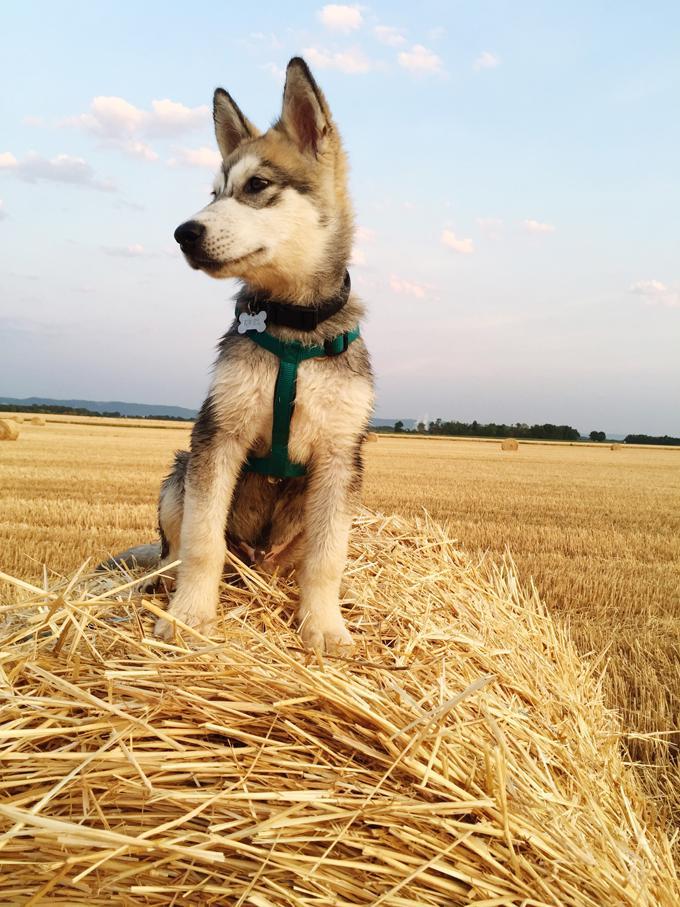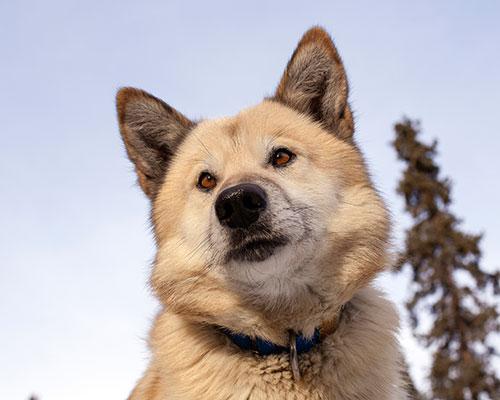The first image is the image on the left, the second image is the image on the right. Analyze the images presented: Is the assertion "The left and right image contains the same number of dogs with one sitting and the other standing outside." valid? Answer yes or no. No. The first image is the image on the left, the second image is the image on the right. Considering the images on both sides, is "Each dog has an open mouth and one dog is wearing a harness." valid? Answer yes or no. No. 